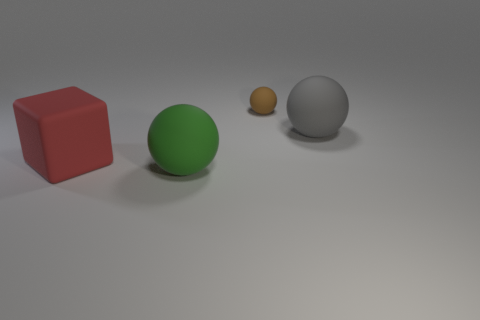There is a thing that is to the left of the small sphere and to the right of the big red matte cube; how big is it?
Give a very brief answer. Large. There is a thing that is behind the green thing and in front of the gray matte ball; what is its shape?
Make the answer very short. Cube. Are there any large spheres that are left of the big sphere in front of the matte thing that is right of the tiny thing?
Offer a very short reply. No. How many things are large rubber spheres that are right of the small brown rubber sphere or large matte spheres that are right of the large green matte sphere?
Your answer should be very brief. 1. Do the ball on the right side of the tiny matte object and the tiny brown sphere have the same material?
Make the answer very short. Yes. There is a ball that is on the left side of the gray thing and in front of the small brown sphere; what material is it made of?
Your response must be concise. Rubber. What color is the thing that is on the left side of the matte sphere that is in front of the gray ball?
Keep it short and to the point. Red. There is a gray thing that is the same shape as the small brown rubber thing; what is it made of?
Your answer should be compact. Rubber. What is the color of the matte ball in front of the big rubber sphere that is on the right side of the big matte sphere that is in front of the block?
Offer a very short reply. Green. What number of objects are either large rubber cylinders or large green matte spheres?
Give a very brief answer. 1. 